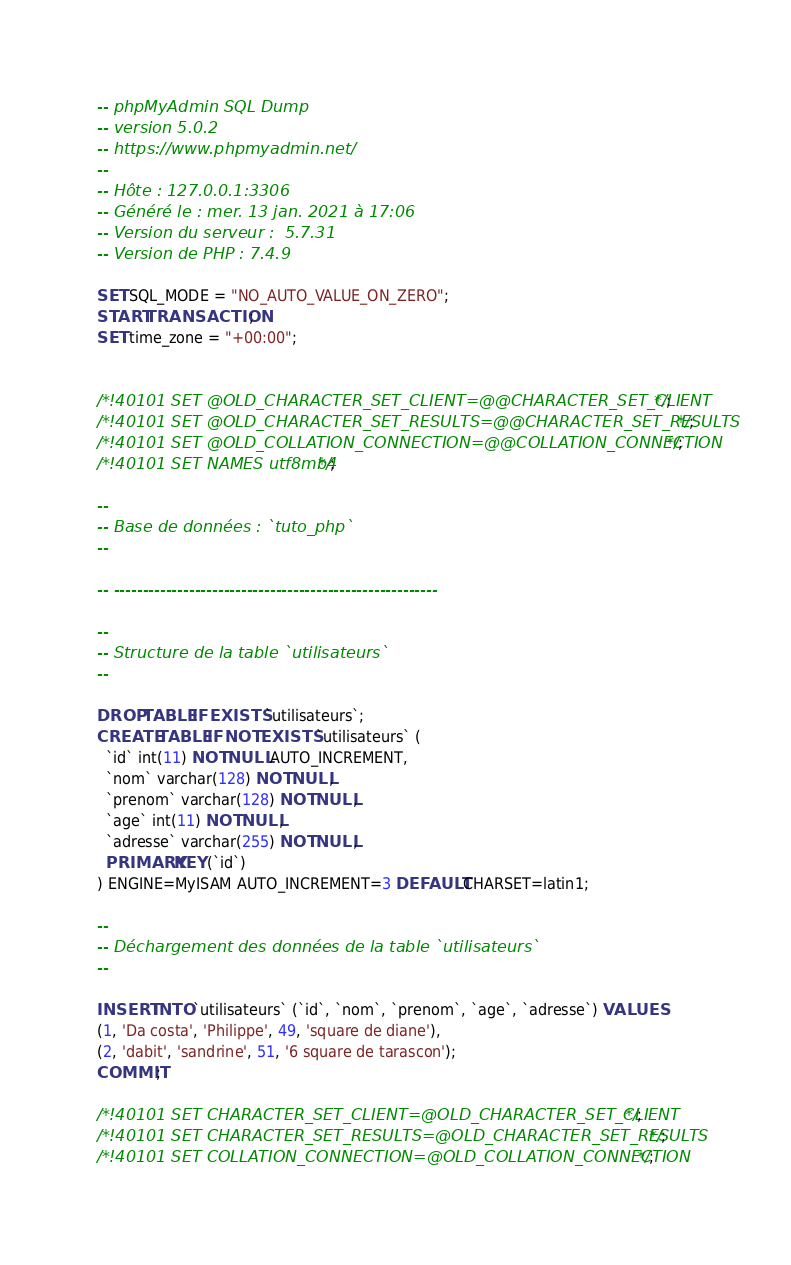<code> <loc_0><loc_0><loc_500><loc_500><_SQL_>-- phpMyAdmin SQL Dump
-- version 5.0.2
-- https://www.phpmyadmin.net/
--
-- Hôte : 127.0.0.1:3306
-- Généré le : mer. 13 jan. 2021 à 17:06
-- Version du serveur :  5.7.31
-- Version de PHP : 7.4.9

SET SQL_MODE = "NO_AUTO_VALUE_ON_ZERO";
START TRANSACTION;
SET time_zone = "+00:00";


/*!40101 SET @OLD_CHARACTER_SET_CLIENT=@@CHARACTER_SET_CLIENT */;
/*!40101 SET @OLD_CHARACTER_SET_RESULTS=@@CHARACTER_SET_RESULTS */;
/*!40101 SET @OLD_COLLATION_CONNECTION=@@COLLATION_CONNECTION */;
/*!40101 SET NAMES utf8mb4 */;

--
-- Base de données : `tuto_php`
--

-- --------------------------------------------------------

--
-- Structure de la table `utilisateurs`
--

DROP TABLE IF EXISTS `utilisateurs`;
CREATE TABLE IF NOT EXISTS `utilisateurs` (
  `id` int(11) NOT NULL AUTO_INCREMENT,
  `nom` varchar(128) NOT NULL,
  `prenom` varchar(128) NOT NULL,
  `age` int(11) NOT NULL,
  `adresse` varchar(255) NOT NULL,
  PRIMARY KEY (`id`)
) ENGINE=MyISAM AUTO_INCREMENT=3 DEFAULT CHARSET=latin1;

--
-- Déchargement des données de la table `utilisateurs`
--

INSERT INTO `utilisateurs` (`id`, `nom`, `prenom`, `age`, `adresse`) VALUES
(1, 'Da costa', 'Philippe', 49, 'square de diane'),
(2, 'dabit', 'sandrine', 51, '6 square de tarascon');
COMMIT;

/*!40101 SET CHARACTER_SET_CLIENT=@OLD_CHARACTER_SET_CLIENT */;
/*!40101 SET CHARACTER_SET_RESULTS=@OLD_CHARACTER_SET_RESULTS */;
/*!40101 SET COLLATION_CONNECTION=@OLD_COLLATION_CONNECTION */;
</code> 